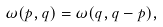Convert formula to latex. <formula><loc_0><loc_0><loc_500><loc_500>\omega ( p , q ) = \omega ( q , q - p ) ,</formula> 